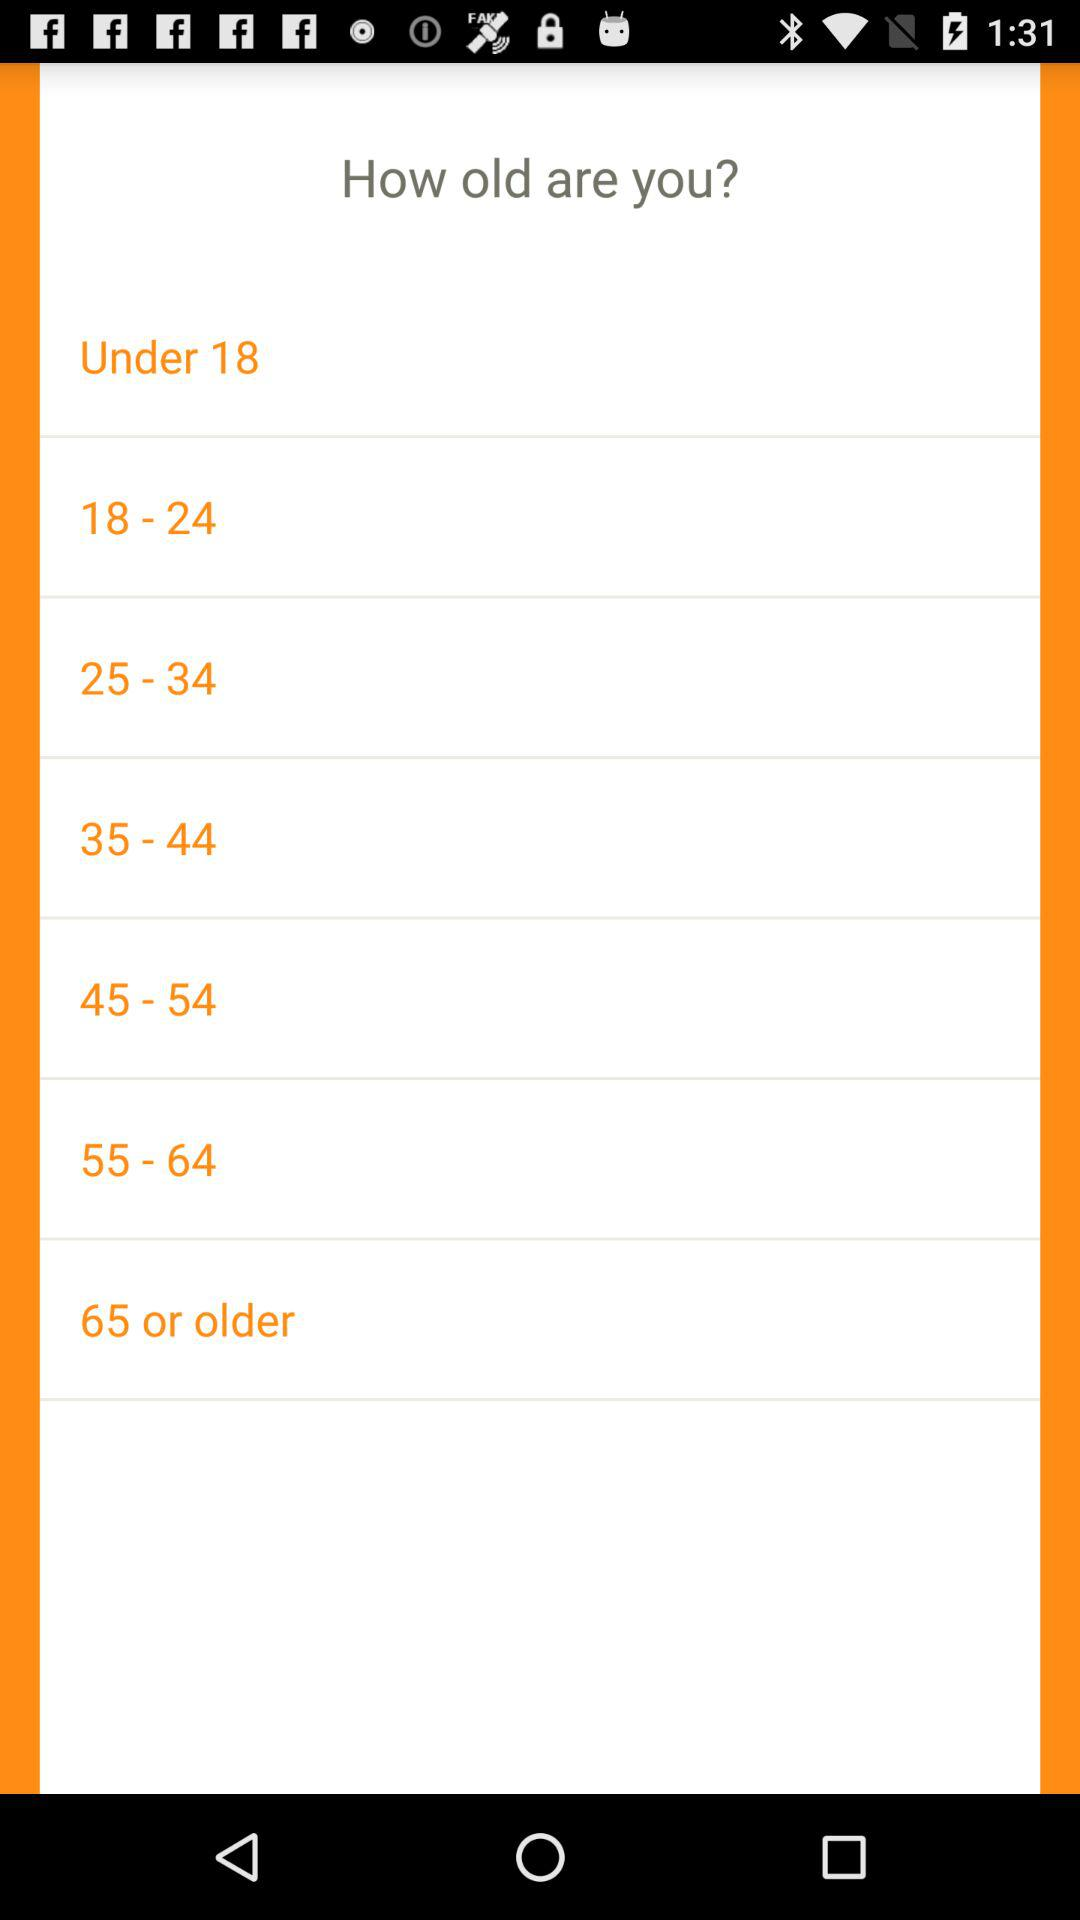How many of the age groups are under 55?
Answer the question using a single word or phrase. 5 